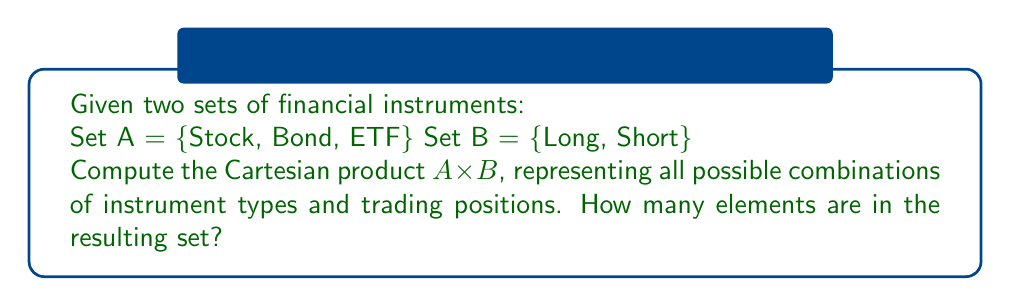What is the answer to this math problem? To solve this problem, we need to understand the concept of Cartesian product and apply it to the given sets of financial instruments.

1. The Cartesian product of two sets A and B, denoted as $A \times B$, is the set of all ordered pairs (a, b) where a ∈ A and b ∈ B.

2. In this case:
   Set A = {Stock, Bond, ETF}
   Set B = {Long, Short}

3. To compute $A \times B$, we pair each element from set A with each element from set B:

   $A \times B$ = {(Stock, Long), (Stock, Short),
                  (Bond, Long), (Bond, Short),
                  (ETF, Long), (ETF, Short)}

4. To determine the number of elements in the Cartesian product:
   - Count the elements in set A: $|A| = 3$
   - Count the elements in set B: $|B| = 2$
   - The number of elements in $A \times B$ is given by $|A| \times |B| = 3 \times 2 = 6$

This result aligns with the number of ordered pairs we listed in step 3.
Answer: The Cartesian product $A \times B$ is:

$A \times B$ = {(Stock, Long), (Stock, Short), (Bond, Long), (Bond, Short), (ETF, Long), (ETF, Short)}

The resulting set contains 6 elements. 